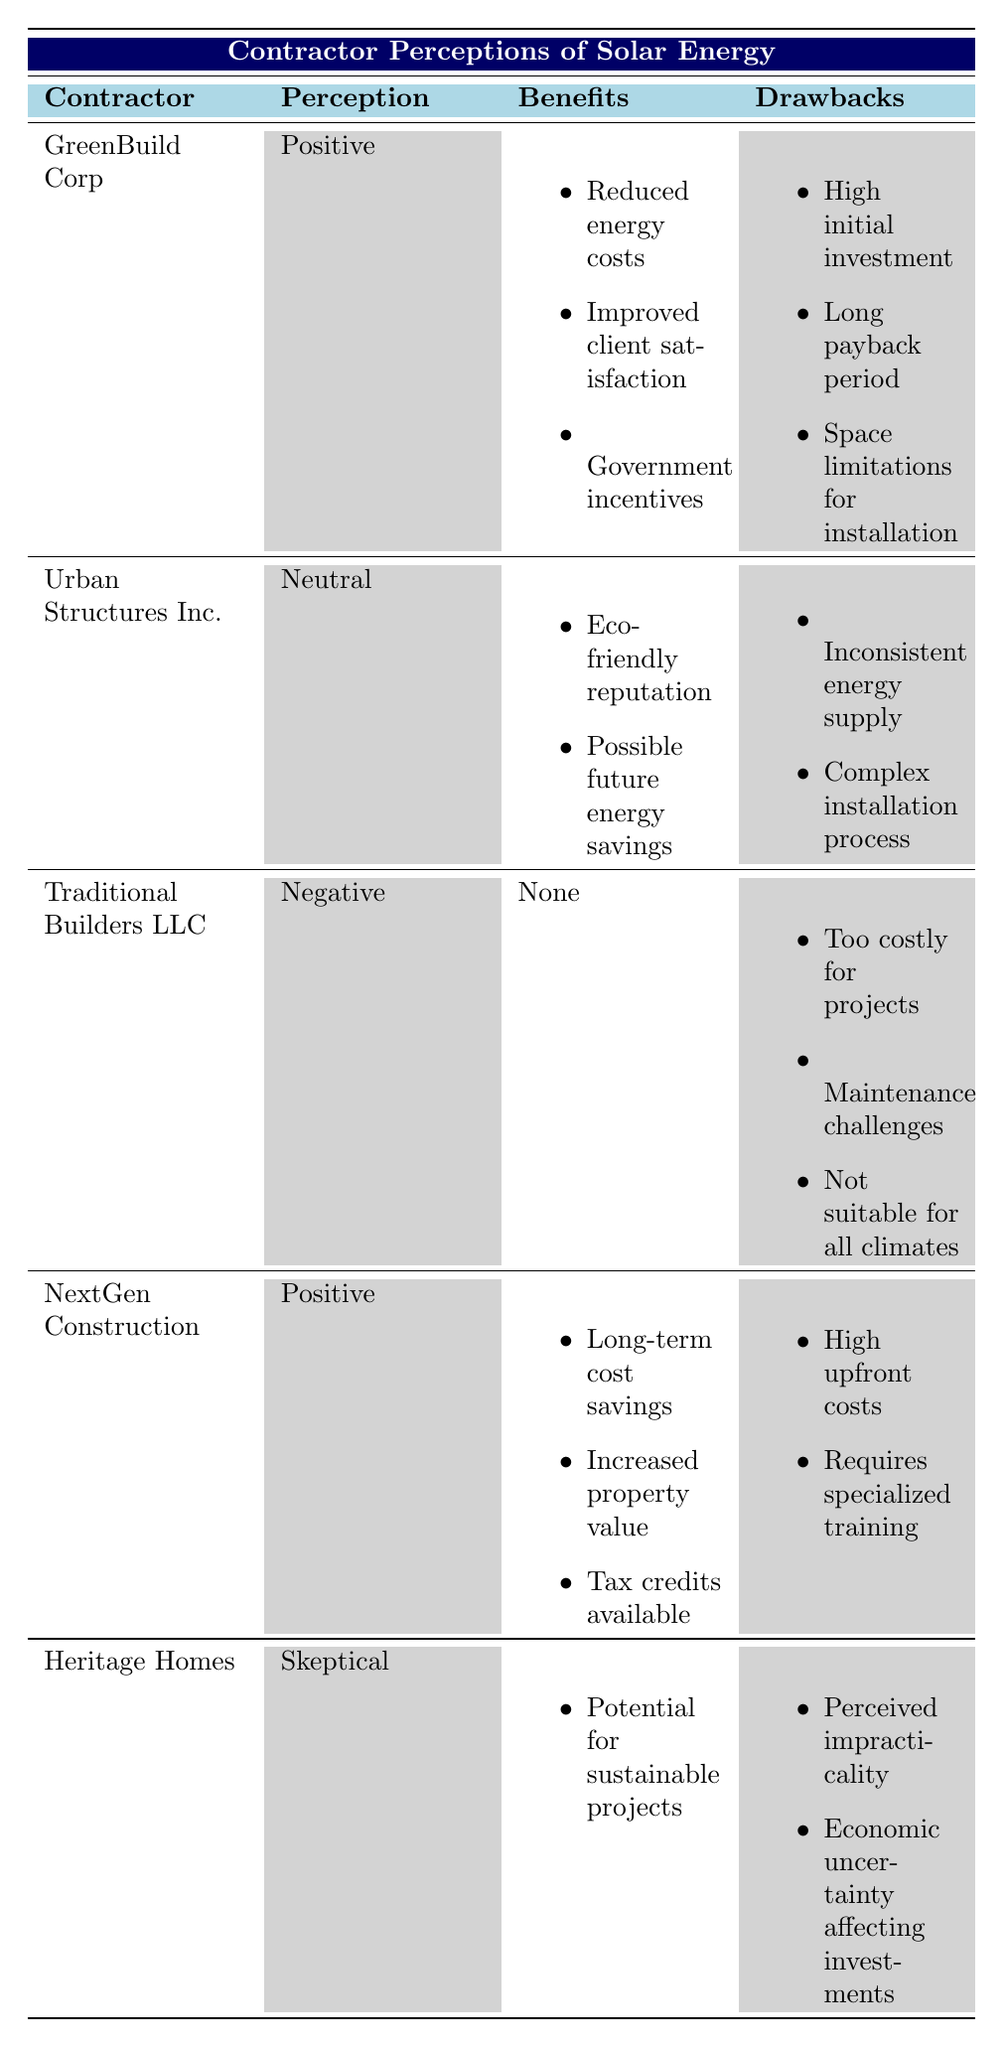What is the perception of Traditional Builders LLC regarding solar energy? The table indicates that Traditional Builders LLC has a negative perception of solar energy. This is directly stated in the "Perception" column for this contractor.
Answer: Negative How many contractors perceive solar energy positively? Looking at the table, GreenBuild Corp and NextGen Construction both have a positive perception of solar energy. Therefore, there are 2 contractors with a positive view.
Answer: 2 What is the most common drawback listed by contractors? The drawback "High initial investment" appears in the drawbacks of both GreenBuild Corp and NextGen Construction. It is likely the most common because it is mentioned explicitly, but checking all rows shows it's the only one mentioned by multiple contractors.
Answer: High initial investment How many benefits does Urban Structures Inc. list? Urban Structures Inc. lists 2 benefits: "Eco-friendly reputation" and "Possible future energy savings." By counting the items in the "Benefits" column for this contractor, we find there are exactly 2.
Answer: 2 Which contractor has the most comprehensive list of drawbacks? Traditional Builders LLC lists 3 drawbacks: "Too costly for projects," "Maintenance challenges," and "Not suitable for all climates," which is the highest number of drawbacks compared to other contractors.
Answer: Traditional Builders LLC Are there any contractors with no listed benefits? Based on the data, Traditional Builders LLC does not list any benefits. This can be verified by checking the "Benefits" section for all contractors.
Answer: Yes What is the total number of drawbacks across all contractors? To find the total, count the drawbacks for each contractor. GreenBuild Corp (3) + Urban Structures Inc. (2) + Traditional Builders LLC (3) + NextGen Construction (2) + Heritage Homes (2) equals 12 total drawbacks.
Answer: 12 Which contractor is skeptical of solar energy and what is one drawback they mention? Heritage Homes is skeptical of solar energy, and one of the drawbacks they mention is "Perceived impracticality." This can be verified by checking their row in the "Perception" and "Drawbacks" columns.
Answer: Heritage Homes; Perceived impracticality What percentage of contractors have a neutral or negative perception of solar energy? There are 5 contractors total, with Urban Structures Inc. having a neutral perception and Traditional Builders LLC negative, so 2 out of 5 fall into these categories. To find the percentage, it is (2/5) * 100% = 40%.
Answer: 40% 